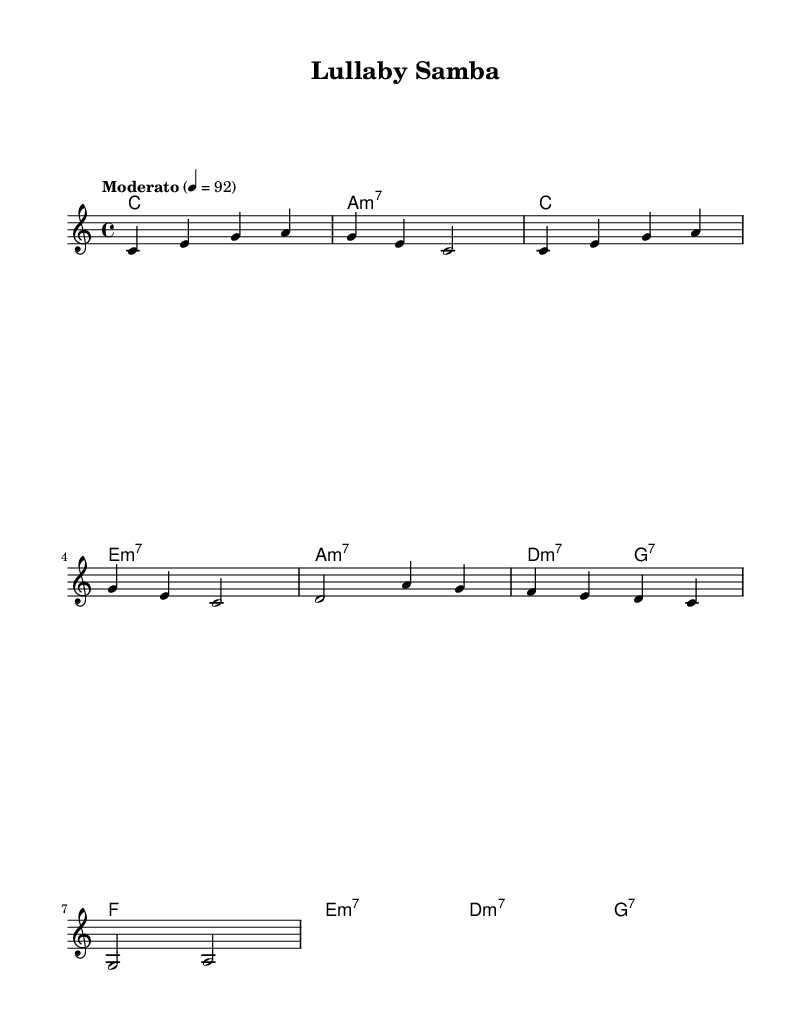What is the key signature of this music? The key signature is indicated at the beginning of the piece. It shows C major, which has no sharps or flats.
Answer: C major What is the time signature of this piece? The time signature is placed right after the key signature. It shows a 4/4 time signature, meaning there are four beats in each measure.
Answer: 4/4 What is the tempo marking of the piece? The tempo marking is mentioned in the header after the time signature. It indicates a moderate speed of 92 beats per minute.
Answer: Moderato, 92 How many measures are in the chorus section? By looking at the chorus section, we can count the measures. The chorus consists of four measures, as there are four groups of music notes separated by vertical lines.
Answer: 4 What type of chord is played in the first measure of the introductory section? The chord in the first measure is a C major chord, as indicated by the chord names written below the melody.
Answer: C What is the relationship between the melody and harmony in the verse section? The melody and harmony in the verse section complement each other. The harmonies provide chord support for the melody notes, and they move together harmonically. The melody notes align with the chord changes marked below them, enhancing the rhythmic and harmonic cohesion.
Answer: Complementary What genre does this music belong to? The title and style indicated in the header suggest that this music is a samba, which is a significant genre within Latin jazz.
Answer: Latin jazz 